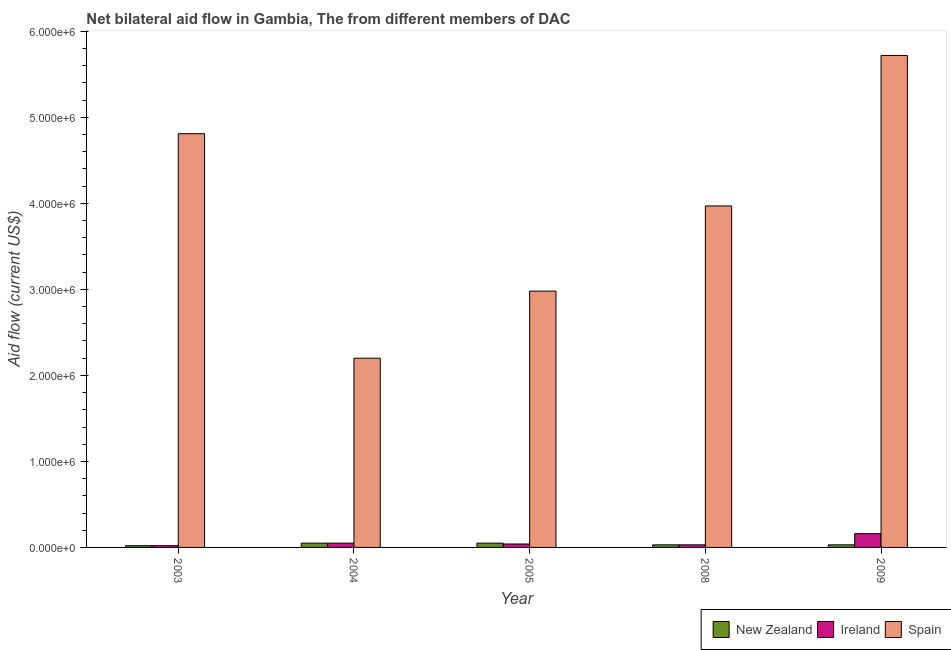Are the number of bars per tick equal to the number of legend labels?
Give a very brief answer. Yes. How many bars are there on the 3rd tick from the left?
Your answer should be compact. 3. How many bars are there on the 1st tick from the right?
Make the answer very short. 3. What is the label of the 1st group of bars from the left?
Make the answer very short. 2003. What is the amount of aid provided by ireland in 2005?
Offer a very short reply. 4.00e+04. Across all years, what is the maximum amount of aid provided by new zealand?
Offer a very short reply. 5.00e+04. Across all years, what is the minimum amount of aid provided by spain?
Provide a short and direct response. 2.20e+06. In which year was the amount of aid provided by new zealand maximum?
Provide a short and direct response. 2004. In which year was the amount of aid provided by new zealand minimum?
Give a very brief answer. 2003. What is the total amount of aid provided by ireland in the graph?
Offer a terse response. 3.00e+05. What is the difference between the amount of aid provided by spain in 2008 and the amount of aid provided by new zealand in 2004?
Provide a succinct answer. 1.77e+06. In the year 2008, what is the difference between the amount of aid provided by new zealand and amount of aid provided by spain?
Your answer should be very brief. 0. What is the ratio of the amount of aid provided by new zealand in 2005 to that in 2008?
Provide a short and direct response. 1.67. Is the amount of aid provided by new zealand in 2008 less than that in 2009?
Ensure brevity in your answer.  No. Is the difference between the amount of aid provided by new zealand in 2003 and 2009 greater than the difference between the amount of aid provided by ireland in 2003 and 2009?
Your response must be concise. No. What is the difference between the highest and the lowest amount of aid provided by spain?
Your answer should be very brief. 3.52e+06. In how many years, is the amount of aid provided by new zealand greater than the average amount of aid provided by new zealand taken over all years?
Ensure brevity in your answer.  2. What does the 1st bar from the left in 2009 represents?
Keep it short and to the point. New Zealand. What does the 2nd bar from the right in 2008 represents?
Make the answer very short. Ireland. Are the values on the major ticks of Y-axis written in scientific E-notation?
Your answer should be compact. Yes. Where does the legend appear in the graph?
Keep it short and to the point. Bottom right. How are the legend labels stacked?
Offer a terse response. Horizontal. What is the title of the graph?
Your response must be concise. Net bilateral aid flow in Gambia, The from different members of DAC. What is the label or title of the X-axis?
Your response must be concise. Year. What is the Aid flow (current US$) in Spain in 2003?
Your response must be concise. 4.81e+06. What is the Aid flow (current US$) of New Zealand in 2004?
Keep it short and to the point. 5.00e+04. What is the Aid flow (current US$) of Spain in 2004?
Your answer should be very brief. 2.20e+06. What is the Aid flow (current US$) in Spain in 2005?
Keep it short and to the point. 2.98e+06. What is the Aid flow (current US$) of New Zealand in 2008?
Offer a very short reply. 3.00e+04. What is the Aid flow (current US$) of Spain in 2008?
Provide a short and direct response. 3.97e+06. What is the Aid flow (current US$) of New Zealand in 2009?
Your answer should be very brief. 3.00e+04. What is the Aid flow (current US$) in Spain in 2009?
Your answer should be very brief. 5.72e+06. Across all years, what is the maximum Aid flow (current US$) of Spain?
Your answer should be very brief. 5.72e+06. Across all years, what is the minimum Aid flow (current US$) of New Zealand?
Keep it short and to the point. 2.00e+04. Across all years, what is the minimum Aid flow (current US$) of Ireland?
Your answer should be very brief. 2.00e+04. Across all years, what is the minimum Aid flow (current US$) of Spain?
Keep it short and to the point. 2.20e+06. What is the total Aid flow (current US$) of Ireland in the graph?
Your answer should be very brief. 3.00e+05. What is the total Aid flow (current US$) in Spain in the graph?
Ensure brevity in your answer.  1.97e+07. What is the difference between the Aid flow (current US$) in New Zealand in 2003 and that in 2004?
Provide a short and direct response. -3.00e+04. What is the difference between the Aid flow (current US$) in Ireland in 2003 and that in 2004?
Ensure brevity in your answer.  -3.00e+04. What is the difference between the Aid flow (current US$) in Spain in 2003 and that in 2004?
Your answer should be compact. 2.61e+06. What is the difference between the Aid flow (current US$) of Spain in 2003 and that in 2005?
Your answer should be very brief. 1.83e+06. What is the difference between the Aid flow (current US$) in New Zealand in 2003 and that in 2008?
Ensure brevity in your answer.  -10000. What is the difference between the Aid flow (current US$) of Ireland in 2003 and that in 2008?
Offer a terse response. -10000. What is the difference between the Aid flow (current US$) of Spain in 2003 and that in 2008?
Offer a terse response. 8.40e+05. What is the difference between the Aid flow (current US$) in Spain in 2003 and that in 2009?
Provide a succinct answer. -9.10e+05. What is the difference between the Aid flow (current US$) of New Zealand in 2004 and that in 2005?
Offer a very short reply. 0. What is the difference between the Aid flow (current US$) in Spain in 2004 and that in 2005?
Your response must be concise. -7.80e+05. What is the difference between the Aid flow (current US$) of Spain in 2004 and that in 2008?
Your answer should be compact. -1.77e+06. What is the difference between the Aid flow (current US$) in New Zealand in 2004 and that in 2009?
Your response must be concise. 2.00e+04. What is the difference between the Aid flow (current US$) of Ireland in 2004 and that in 2009?
Provide a short and direct response. -1.10e+05. What is the difference between the Aid flow (current US$) in Spain in 2004 and that in 2009?
Offer a terse response. -3.52e+06. What is the difference between the Aid flow (current US$) in New Zealand in 2005 and that in 2008?
Your response must be concise. 2.00e+04. What is the difference between the Aid flow (current US$) in Ireland in 2005 and that in 2008?
Make the answer very short. 10000. What is the difference between the Aid flow (current US$) in Spain in 2005 and that in 2008?
Provide a succinct answer. -9.90e+05. What is the difference between the Aid flow (current US$) of Ireland in 2005 and that in 2009?
Offer a very short reply. -1.20e+05. What is the difference between the Aid flow (current US$) of Spain in 2005 and that in 2009?
Offer a terse response. -2.74e+06. What is the difference between the Aid flow (current US$) in New Zealand in 2008 and that in 2009?
Offer a terse response. 0. What is the difference between the Aid flow (current US$) in Ireland in 2008 and that in 2009?
Your answer should be very brief. -1.30e+05. What is the difference between the Aid flow (current US$) in Spain in 2008 and that in 2009?
Offer a very short reply. -1.75e+06. What is the difference between the Aid flow (current US$) in New Zealand in 2003 and the Aid flow (current US$) in Ireland in 2004?
Ensure brevity in your answer.  -3.00e+04. What is the difference between the Aid flow (current US$) of New Zealand in 2003 and the Aid flow (current US$) of Spain in 2004?
Provide a short and direct response. -2.18e+06. What is the difference between the Aid flow (current US$) in Ireland in 2003 and the Aid flow (current US$) in Spain in 2004?
Offer a very short reply. -2.18e+06. What is the difference between the Aid flow (current US$) of New Zealand in 2003 and the Aid flow (current US$) of Spain in 2005?
Keep it short and to the point. -2.96e+06. What is the difference between the Aid flow (current US$) of Ireland in 2003 and the Aid flow (current US$) of Spain in 2005?
Give a very brief answer. -2.96e+06. What is the difference between the Aid flow (current US$) of New Zealand in 2003 and the Aid flow (current US$) of Spain in 2008?
Provide a succinct answer. -3.95e+06. What is the difference between the Aid flow (current US$) in Ireland in 2003 and the Aid flow (current US$) in Spain in 2008?
Make the answer very short. -3.95e+06. What is the difference between the Aid flow (current US$) in New Zealand in 2003 and the Aid flow (current US$) in Spain in 2009?
Provide a succinct answer. -5.70e+06. What is the difference between the Aid flow (current US$) of Ireland in 2003 and the Aid flow (current US$) of Spain in 2009?
Ensure brevity in your answer.  -5.70e+06. What is the difference between the Aid flow (current US$) in New Zealand in 2004 and the Aid flow (current US$) in Spain in 2005?
Provide a short and direct response. -2.93e+06. What is the difference between the Aid flow (current US$) of Ireland in 2004 and the Aid flow (current US$) of Spain in 2005?
Offer a terse response. -2.93e+06. What is the difference between the Aid flow (current US$) in New Zealand in 2004 and the Aid flow (current US$) in Ireland in 2008?
Provide a short and direct response. 2.00e+04. What is the difference between the Aid flow (current US$) of New Zealand in 2004 and the Aid flow (current US$) of Spain in 2008?
Offer a very short reply. -3.92e+06. What is the difference between the Aid flow (current US$) of Ireland in 2004 and the Aid flow (current US$) of Spain in 2008?
Make the answer very short. -3.92e+06. What is the difference between the Aid flow (current US$) of New Zealand in 2004 and the Aid flow (current US$) of Ireland in 2009?
Provide a short and direct response. -1.10e+05. What is the difference between the Aid flow (current US$) in New Zealand in 2004 and the Aid flow (current US$) in Spain in 2009?
Offer a very short reply. -5.67e+06. What is the difference between the Aid flow (current US$) in Ireland in 2004 and the Aid flow (current US$) in Spain in 2009?
Your answer should be very brief. -5.67e+06. What is the difference between the Aid flow (current US$) in New Zealand in 2005 and the Aid flow (current US$) in Ireland in 2008?
Offer a terse response. 2.00e+04. What is the difference between the Aid flow (current US$) of New Zealand in 2005 and the Aid flow (current US$) of Spain in 2008?
Make the answer very short. -3.92e+06. What is the difference between the Aid flow (current US$) of Ireland in 2005 and the Aid flow (current US$) of Spain in 2008?
Provide a succinct answer. -3.93e+06. What is the difference between the Aid flow (current US$) of New Zealand in 2005 and the Aid flow (current US$) of Ireland in 2009?
Your response must be concise. -1.10e+05. What is the difference between the Aid flow (current US$) in New Zealand in 2005 and the Aid flow (current US$) in Spain in 2009?
Your answer should be compact. -5.67e+06. What is the difference between the Aid flow (current US$) of Ireland in 2005 and the Aid flow (current US$) of Spain in 2009?
Give a very brief answer. -5.68e+06. What is the difference between the Aid flow (current US$) in New Zealand in 2008 and the Aid flow (current US$) in Spain in 2009?
Keep it short and to the point. -5.69e+06. What is the difference between the Aid flow (current US$) in Ireland in 2008 and the Aid flow (current US$) in Spain in 2009?
Give a very brief answer. -5.69e+06. What is the average Aid flow (current US$) in New Zealand per year?
Offer a very short reply. 3.60e+04. What is the average Aid flow (current US$) of Ireland per year?
Provide a succinct answer. 6.00e+04. What is the average Aid flow (current US$) in Spain per year?
Offer a very short reply. 3.94e+06. In the year 2003, what is the difference between the Aid flow (current US$) of New Zealand and Aid flow (current US$) of Ireland?
Offer a very short reply. 0. In the year 2003, what is the difference between the Aid flow (current US$) in New Zealand and Aid flow (current US$) in Spain?
Provide a short and direct response. -4.79e+06. In the year 2003, what is the difference between the Aid flow (current US$) in Ireland and Aid flow (current US$) in Spain?
Ensure brevity in your answer.  -4.79e+06. In the year 2004, what is the difference between the Aid flow (current US$) in New Zealand and Aid flow (current US$) in Ireland?
Your response must be concise. 0. In the year 2004, what is the difference between the Aid flow (current US$) in New Zealand and Aid flow (current US$) in Spain?
Your answer should be compact. -2.15e+06. In the year 2004, what is the difference between the Aid flow (current US$) in Ireland and Aid flow (current US$) in Spain?
Your answer should be compact. -2.15e+06. In the year 2005, what is the difference between the Aid flow (current US$) in New Zealand and Aid flow (current US$) in Spain?
Provide a succinct answer. -2.93e+06. In the year 2005, what is the difference between the Aid flow (current US$) in Ireland and Aid flow (current US$) in Spain?
Ensure brevity in your answer.  -2.94e+06. In the year 2008, what is the difference between the Aid flow (current US$) of New Zealand and Aid flow (current US$) of Ireland?
Provide a succinct answer. 0. In the year 2008, what is the difference between the Aid flow (current US$) in New Zealand and Aid flow (current US$) in Spain?
Provide a short and direct response. -3.94e+06. In the year 2008, what is the difference between the Aid flow (current US$) of Ireland and Aid flow (current US$) of Spain?
Your answer should be very brief. -3.94e+06. In the year 2009, what is the difference between the Aid flow (current US$) in New Zealand and Aid flow (current US$) in Spain?
Provide a short and direct response. -5.69e+06. In the year 2009, what is the difference between the Aid flow (current US$) in Ireland and Aid flow (current US$) in Spain?
Offer a terse response. -5.56e+06. What is the ratio of the Aid flow (current US$) of Ireland in 2003 to that in 2004?
Your response must be concise. 0.4. What is the ratio of the Aid flow (current US$) of Spain in 2003 to that in 2004?
Provide a succinct answer. 2.19. What is the ratio of the Aid flow (current US$) of Ireland in 2003 to that in 2005?
Your response must be concise. 0.5. What is the ratio of the Aid flow (current US$) of Spain in 2003 to that in 2005?
Provide a succinct answer. 1.61. What is the ratio of the Aid flow (current US$) in New Zealand in 2003 to that in 2008?
Your response must be concise. 0.67. What is the ratio of the Aid flow (current US$) in Spain in 2003 to that in 2008?
Offer a very short reply. 1.21. What is the ratio of the Aid flow (current US$) of Spain in 2003 to that in 2009?
Provide a short and direct response. 0.84. What is the ratio of the Aid flow (current US$) in New Zealand in 2004 to that in 2005?
Your answer should be very brief. 1. What is the ratio of the Aid flow (current US$) of Ireland in 2004 to that in 2005?
Offer a terse response. 1.25. What is the ratio of the Aid flow (current US$) in Spain in 2004 to that in 2005?
Provide a succinct answer. 0.74. What is the ratio of the Aid flow (current US$) in Ireland in 2004 to that in 2008?
Make the answer very short. 1.67. What is the ratio of the Aid flow (current US$) in Spain in 2004 to that in 2008?
Give a very brief answer. 0.55. What is the ratio of the Aid flow (current US$) of Ireland in 2004 to that in 2009?
Make the answer very short. 0.31. What is the ratio of the Aid flow (current US$) of Spain in 2004 to that in 2009?
Provide a succinct answer. 0.38. What is the ratio of the Aid flow (current US$) in New Zealand in 2005 to that in 2008?
Your answer should be compact. 1.67. What is the ratio of the Aid flow (current US$) of Ireland in 2005 to that in 2008?
Your answer should be very brief. 1.33. What is the ratio of the Aid flow (current US$) of Spain in 2005 to that in 2008?
Offer a very short reply. 0.75. What is the ratio of the Aid flow (current US$) of New Zealand in 2005 to that in 2009?
Your response must be concise. 1.67. What is the ratio of the Aid flow (current US$) in Ireland in 2005 to that in 2009?
Offer a very short reply. 0.25. What is the ratio of the Aid flow (current US$) of Spain in 2005 to that in 2009?
Provide a succinct answer. 0.52. What is the ratio of the Aid flow (current US$) of New Zealand in 2008 to that in 2009?
Provide a short and direct response. 1. What is the ratio of the Aid flow (current US$) in Ireland in 2008 to that in 2009?
Ensure brevity in your answer.  0.19. What is the ratio of the Aid flow (current US$) in Spain in 2008 to that in 2009?
Your answer should be compact. 0.69. What is the difference between the highest and the second highest Aid flow (current US$) in New Zealand?
Keep it short and to the point. 0. What is the difference between the highest and the second highest Aid flow (current US$) of Spain?
Your answer should be compact. 9.10e+05. What is the difference between the highest and the lowest Aid flow (current US$) in Spain?
Keep it short and to the point. 3.52e+06. 